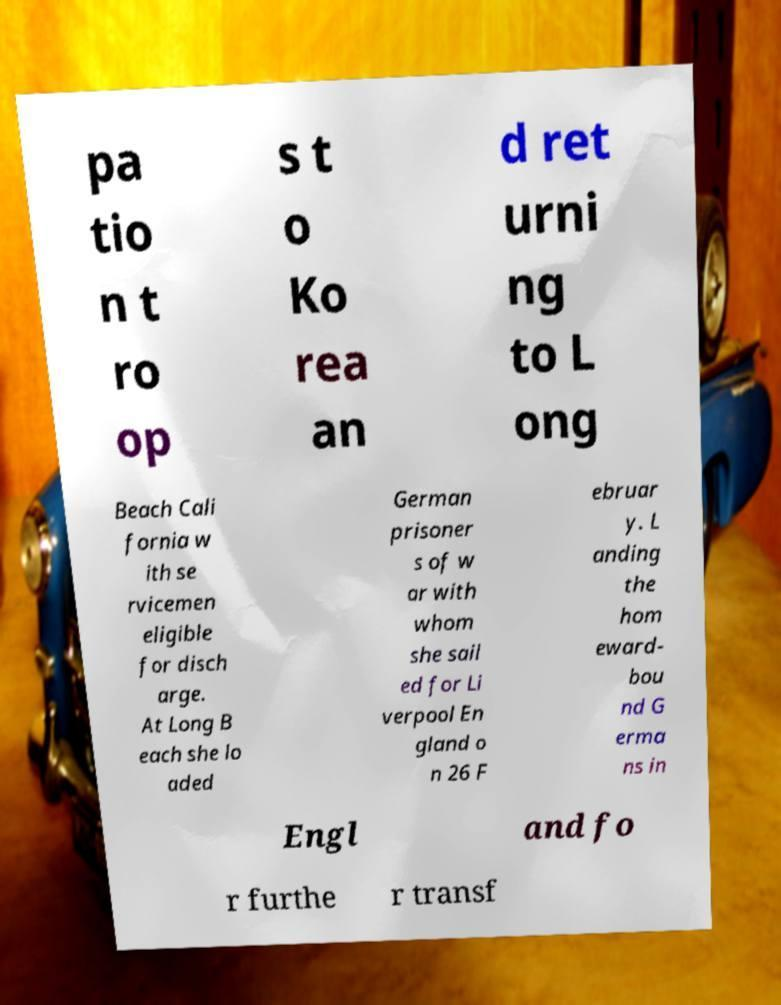Could you assist in decoding the text presented in this image and type it out clearly? pa tio n t ro op s t o Ko rea an d ret urni ng to L ong Beach Cali fornia w ith se rvicemen eligible for disch arge. At Long B each she lo aded German prisoner s of w ar with whom she sail ed for Li verpool En gland o n 26 F ebruar y. L anding the hom eward- bou nd G erma ns in Engl and fo r furthe r transf 